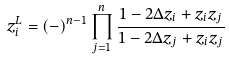Convert formula to latex. <formula><loc_0><loc_0><loc_500><loc_500>z _ { i } ^ { L } = ( - ) ^ { n - 1 } \prod _ { j = 1 } ^ { n } \frac { 1 - 2 \Delta z _ { i } + z _ { i } z _ { j } } { 1 - 2 \Delta z _ { j } + z _ { i } z _ { j } }</formula> 